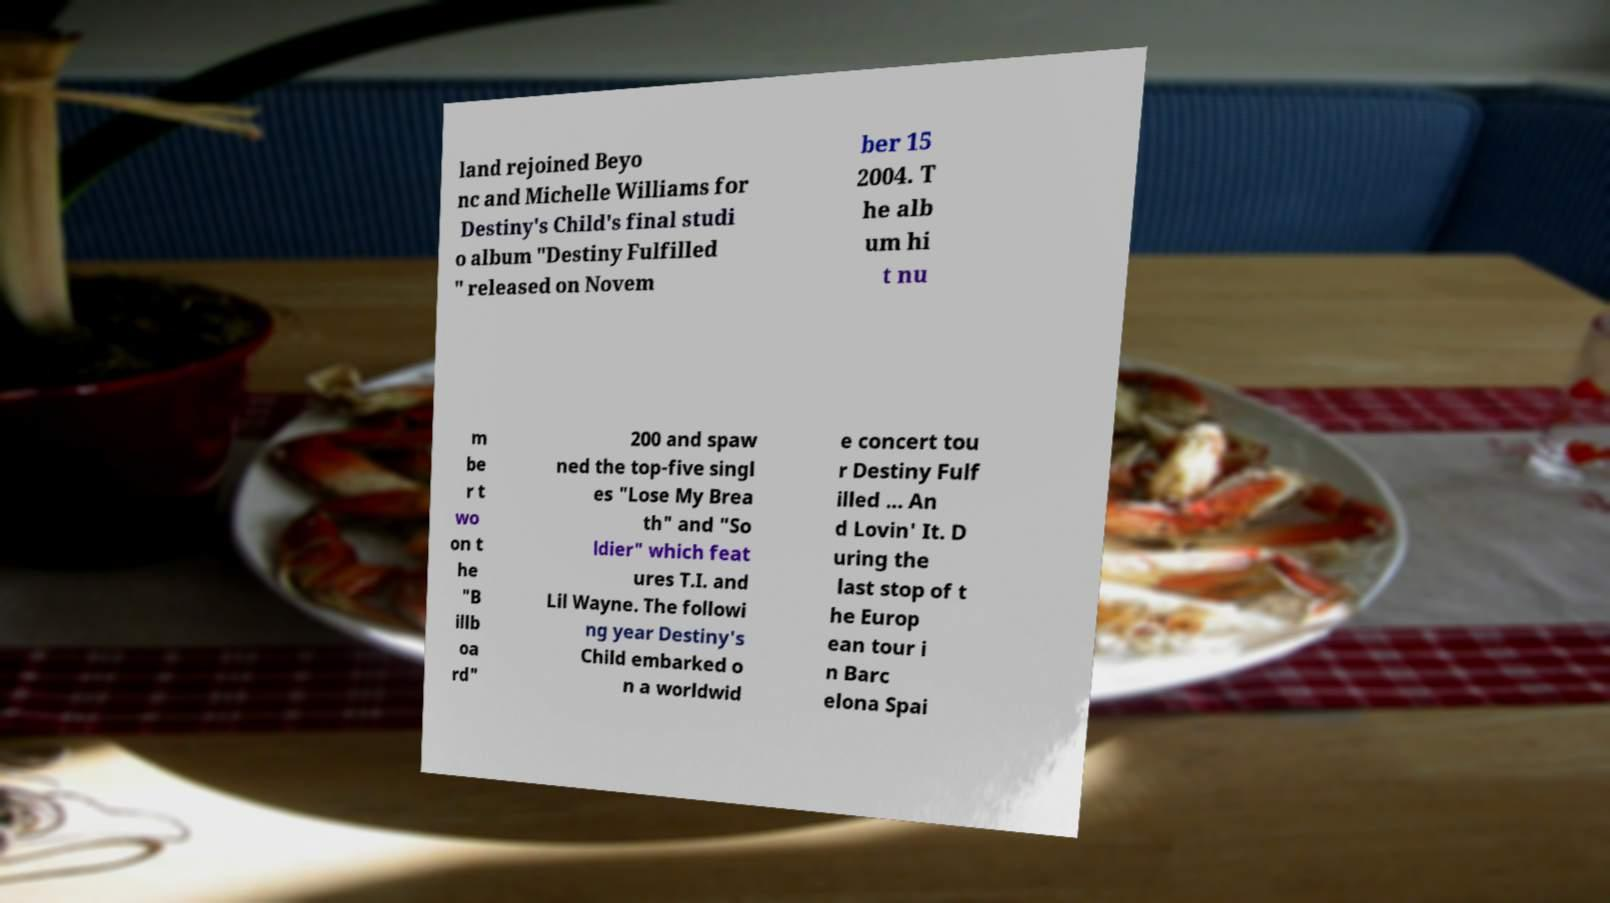Could you extract and type out the text from this image? land rejoined Beyo nc and Michelle Williams for Destiny's Child's final studi o album "Destiny Fulfilled " released on Novem ber 15 2004. T he alb um hi t nu m be r t wo on t he "B illb oa rd" 200 and spaw ned the top-five singl es "Lose My Brea th" and "So ldier" which feat ures T.I. and Lil Wayne. The followi ng year Destiny's Child embarked o n a worldwid e concert tou r Destiny Fulf illed ... An d Lovin' It. D uring the last stop of t he Europ ean tour i n Barc elona Spai 